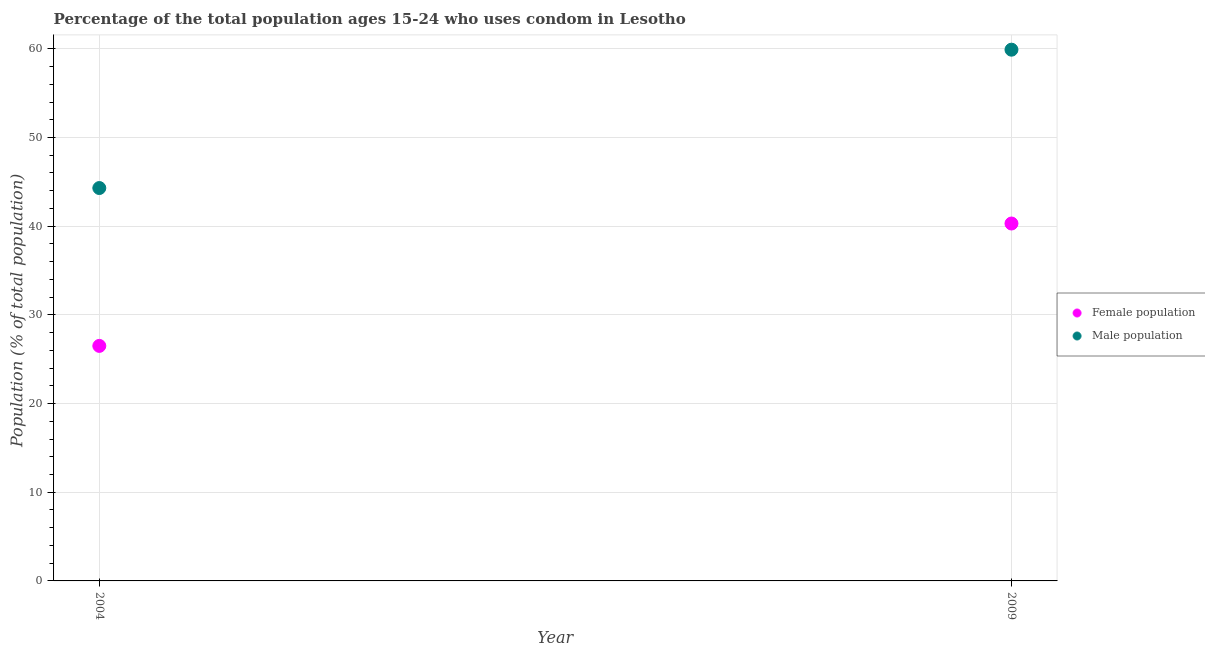How many different coloured dotlines are there?
Give a very brief answer. 2. Is the number of dotlines equal to the number of legend labels?
Keep it short and to the point. Yes. What is the male population in 2009?
Your answer should be very brief. 59.9. Across all years, what is the maximum male population?
Your answer should be compact. 59.9. In which year was the female population maximum?
Make the answer very short. 2009. In which year was the male population minimum?
Offer a very short reply. 2004. What is the total female population in the graph?
Make the answer very short. 66.8. What is the difference between the female population in 2004 and that in 2009?
Ensure brevity in your answer.  -13.8. What is the difference between the female population in 2004 and the male population in 2009?
Keep it short and to the point. -33.4. What is the average male population per year?
Make the answer very short. 52.1. In the year 2004, what is the difference between the female population and male population?
Offer a very short reply. -17.8. What is the ratio of the male population in 2004 to that in 2009?
Your answer should be compact. 0.74. In how many years, is the male population greater than the average male population taken over all years?
Provide a short and direct response. 1. Does the female population monotonically increase over the years?
Your answer should be very brief. Yes. Is the male population strictly greater than the female population over the years?
Offer a terse response. Yes. Is the male population strictly less than the female population over the years?
Give a very brief answer. No. How many years are there in the graph?
Keep it short and to the point. 2. What is the difference between two consecutive major ticks on the Y-axis?
Ensure brevity in your answer.  10. Does the graph contain any zero values?
Provide a short and direct response. No. Does the graph contain grids?
Make the answer very short. Yes. Where does the legend appear in the graph?
Your answer should be very brief. Center right. What is the title of the graph?
Provide a short and direct response. Percentage of the total population ages 15-24 who uses condom in Lesotho. What is the label or title of the X-axis?
Give a very brief answer. Year. What is the label or title of the Y-axis?
Offer a very short reply. Population (% of total population) . What is the Population (% of total population)  in Male population in 2004?
Provide a short and direct response. 44.3. What is the Population (% of total population)  of Female population in 2009?
Keep it short and to the point. 40.3. What is the Population (% of total population)  in Male population in 2009?
Offer a terse response. 59.9. Across all years, what is the maximum Population (% of total population)  of Female population?
Give a very brief answer. 40.3. Across all years, what is the maximum Population (% of total population)  of Male population?
Offer a terse response. 59.9. Across all years, what is the minimum Population (% of total population)  in Female population?
Your answer should be very brief. 26.5. Across all years, what is the minimum Population (% of total population)  of Male population?
Provide a succinct answer. 44.3. What is the total Population (% of total population)  in Female population in the graph?
Keep it short and to the point. 66.8. What is the total Population (% of total population)  of Male population in the graph?
Make the answer very short. 104.2. What is the difference between the Population (% of total population)  of Female population in 2004 and that in 2009?
Keep it short and to the point. -13.8. What is the difference between the Population (% of total population)  in Male population in 2004 and that in 2009?
Your response must be concise. -15.6. What is the difference between the Population (% of total population)  of Female population in 2004 and the Population (% of total population)  of Male population in 2009?
Keep it short and to the point. -33.4. What is the average Population (% of total population)  of Female population per year?
Your answer should be very brief. 33.4. What is the average Population (% of total population)  of Male population per year?
Your response must be concise. 52.1. In the year 2004, what is the difference between the Population (% of total population)  of Female population and Population (% of total population)  of Male population?
Offer a very short reply. -17.8. In the year 2009, what is the difference between the Population (% of total population)  of Female population and Population (% of total population)  of Male population?
Your answer should be very brief. -19.6. What is the ratio of the Population (% of total population)  of Female population in 2004 to that in 2009?
Keep it short and to the point. 0.66. What is the ratio of the Population (% of total population)  of Male population in 2004 to that in 2009?
Offer a very short reply. 0.74. What is the difference between the highest and the second highest Population (% of total population)  of Male population?
Provide a succinct answer. 15.6. What is the difference between the highest and the lowest Population (% of total population)  in Female population?
Your response must be concise. 13.8. What is the difference between the highest and the lowest Population (% of total population)  in Male population?
Your response must be concise. 15.6. 